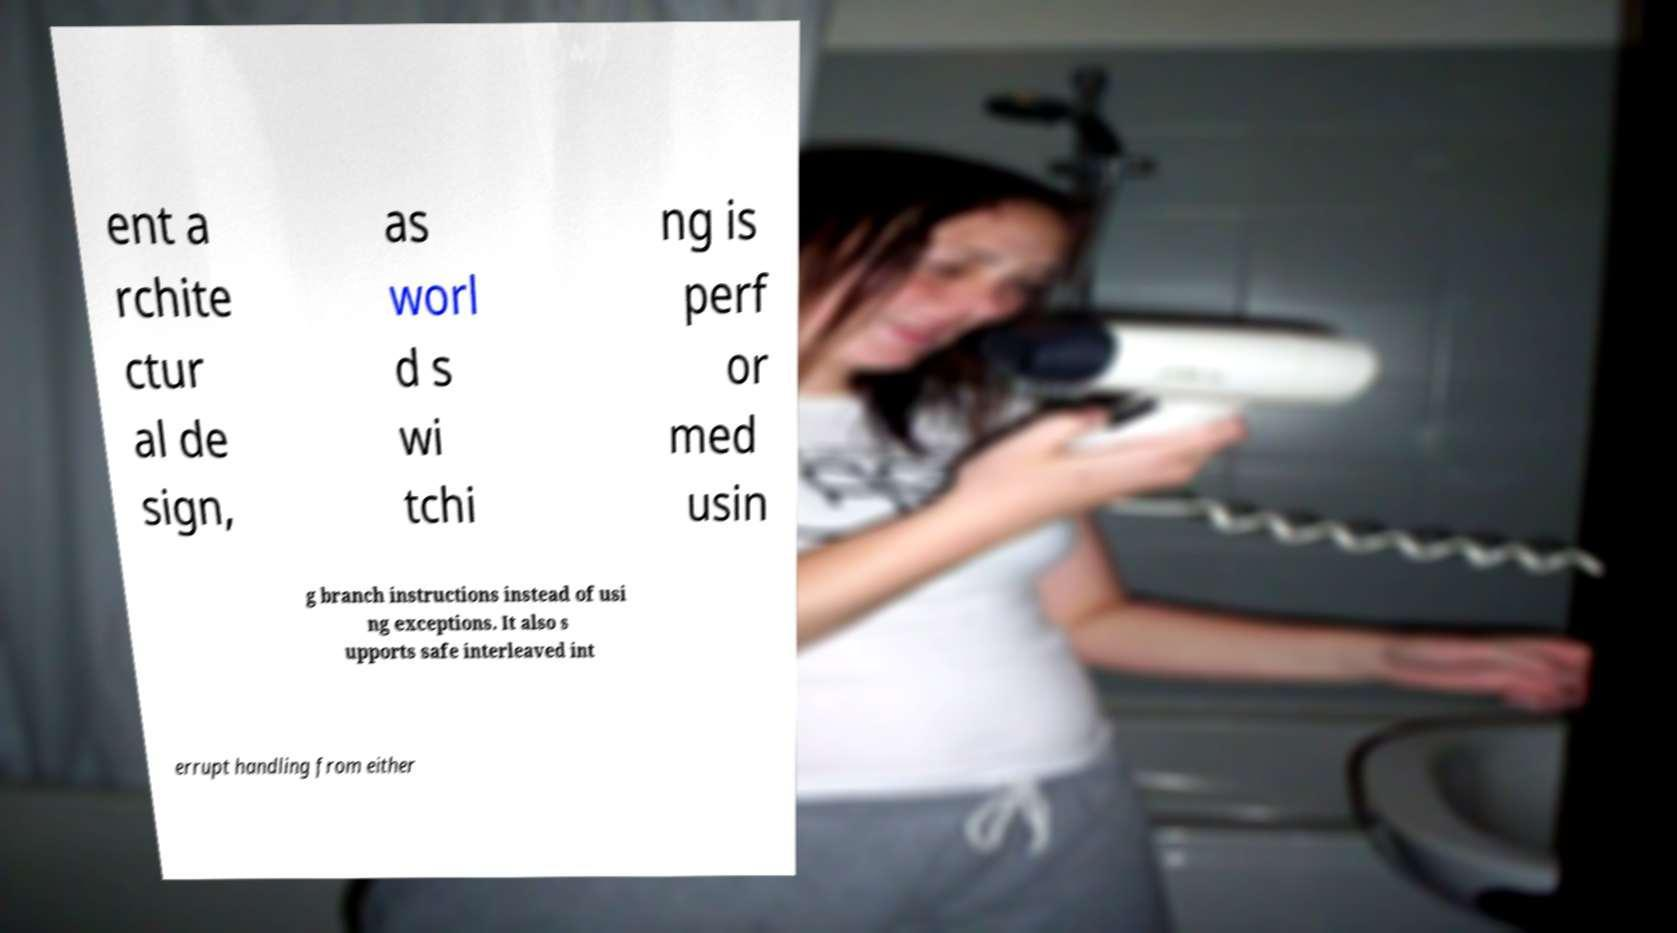What messages or text are displayed in this image? I need them in a readable, typed format. ent a rchite ctur al de sign, as worl d s wi tchi ng is perf or med usin g branch instructions instead of usi ng exceptions. It also s upports safe interleaved int errupt handling from either 